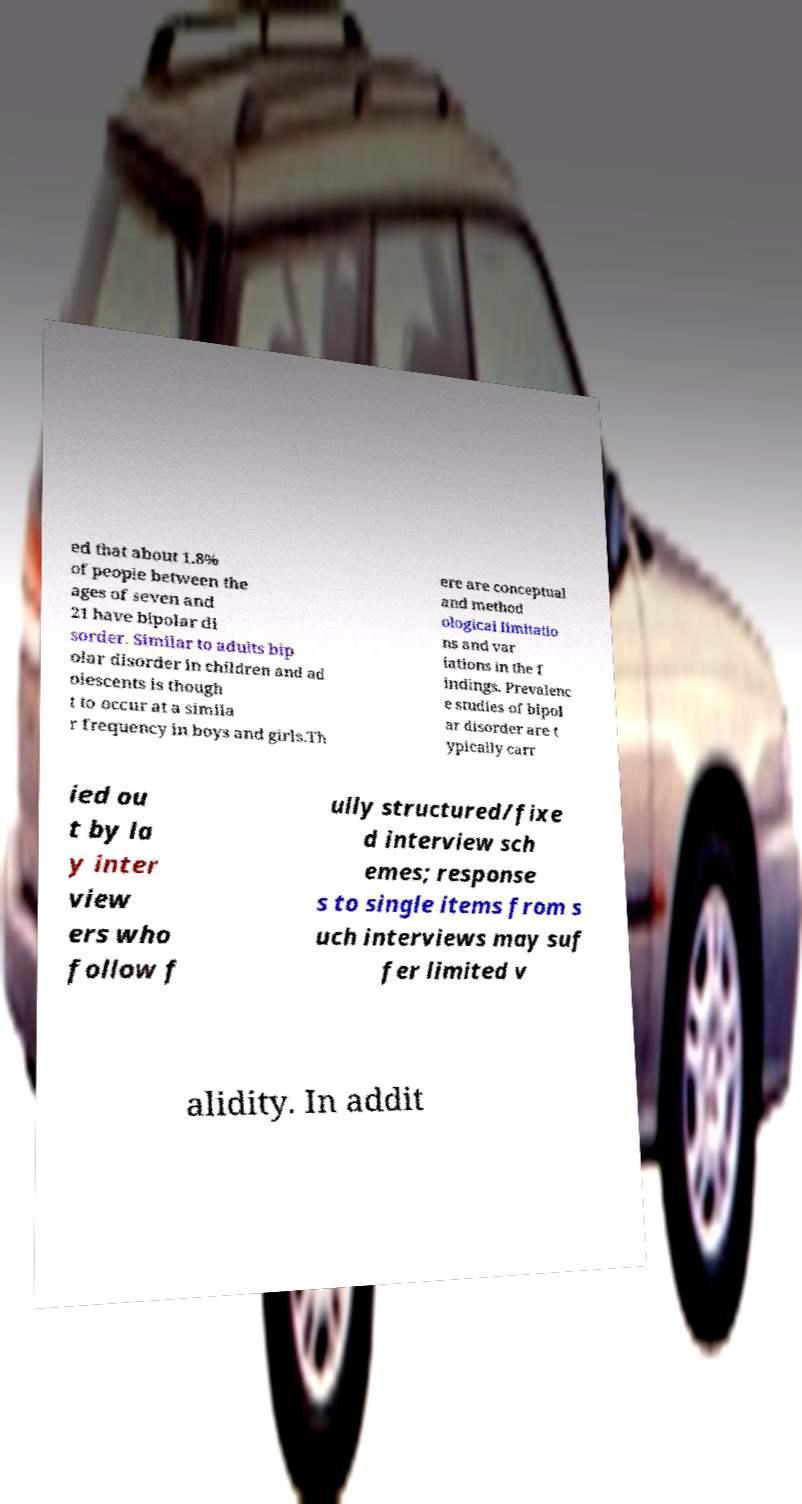Can you accurately transcribe the text from the provided image for me? ed that about 1.8% of people between the ages of seven and 21 have bipolar di sorder. Similar to adults bip olar disorder in children and ad olescents is though t to occur at a simila r frequency in boys and girls.Th ere are conceptual and method ological limitatio ns and var iations in the f indings. Prevalenc e studies of bipol ar disorder are t ypically carr ied ou t by la y inter view ers who follow f ully structured/fixe d interview sch emes; response s to single items from s uch interviews may suf fer limited v alidity. In addit 